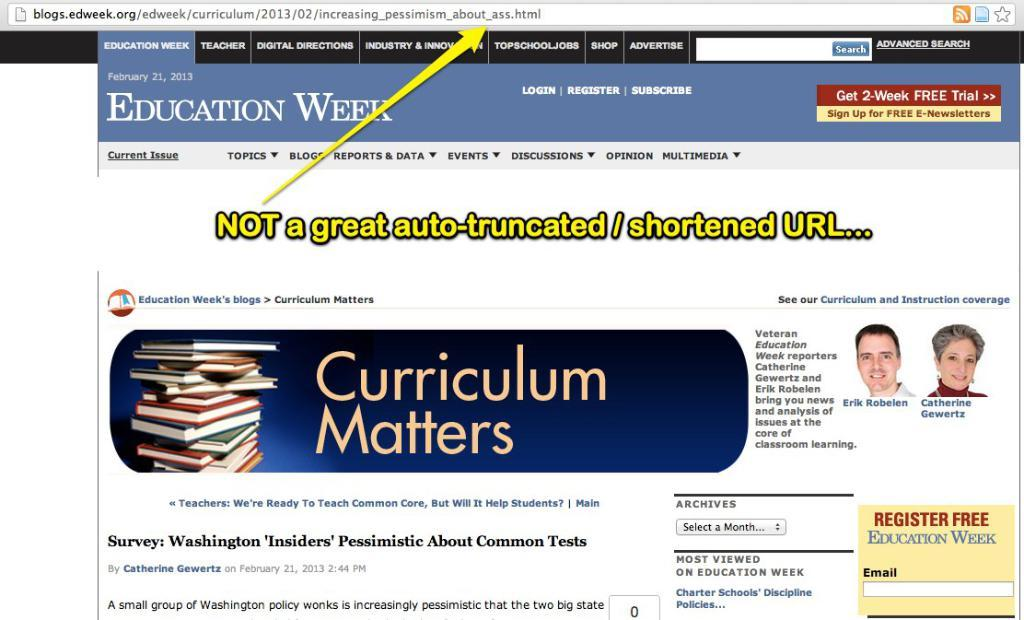<image>
Share a concise interpretation of the image provided. A website titled Education Week with an arrow pointing out a bad URL 